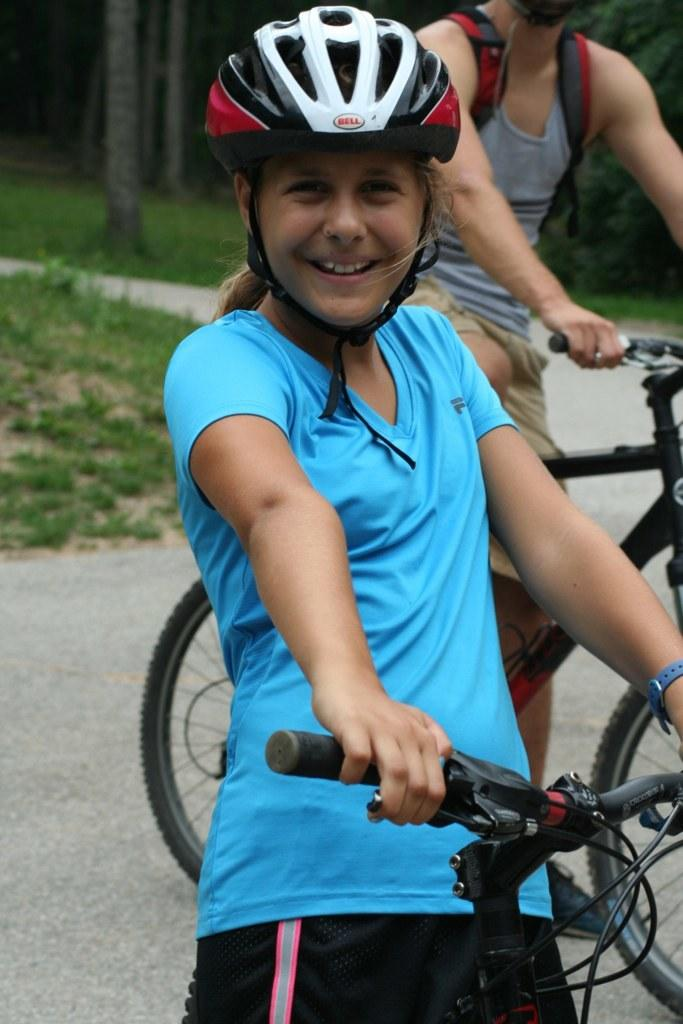How many people are in the image? There are two persons in the image. What are the persons doing in the image? The persons are standing and holding bicycles. What type of terrain is visible in the image? There is grass visible in the image. What can be seen in the background of the image? There are trees in the background of the image. What type of books are the persons folding in the image? There are no books present in the image; the persons are holding bicycles. What is the color of the slip that the persons are wearing in the image? There is no mention of any slip or clothing in the image; the persons are holding bicycles. 